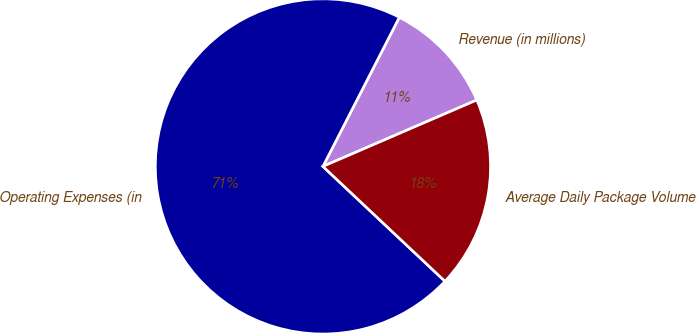<chart> <loc_0><loc_0><loc_500><loc_500><pie_chart><fcel>Revenue (in millions)<fcel>Operating Expenses (in<fcel>Average Daily Package Volume<nl><fcel>10.98%<fcel>70.52%<fcel>18.5%<nl></chart> 